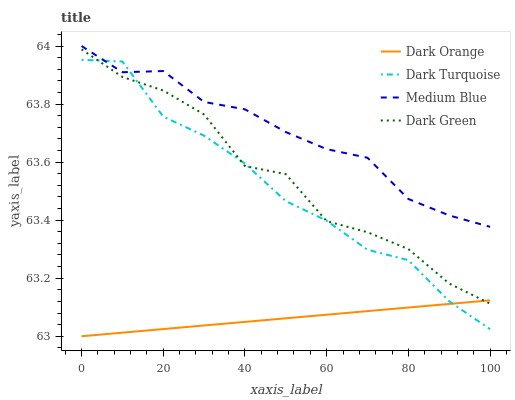Does Dark Orange have the minimum area under the curve?
Answer yes or no. Yes. Does Medium Blue have the maximum area under the curve?
Answer yes or no. Yes. Does Dark Green have the minimum area under the curve?
Answer yes or no. No. Does Dark Green have the maximum area under the curve?
Answer yes or no. No. Is Dark Orange the smoothest?
Answer yes or no. Yes. Is Dark Green the roughest?
Answer yes or no. Yes. Is Medium Blue the smoothest?
Answer yes or no. No. Is Medium Blue the roughest?
Answer yes or no. No. Does Dark Orange have the lowest value?
Answer yes or no. Yes. Does Dark Green have the lowest value?
Answer yes or no. No. Does Medium Blue have the highest value?
Answer yes or no. Yes. Does Dark Green have the highest value?
Answer yes or no. No. Is Dark Green less than Medium Blue?
Answer yes or no. Yes. Is Medium Blue greater than Dark Orange?
Answer yes or no. Yes. Does Dark Turquoise intersect Medium Blue?
Answer yes or no. Yes. Is Dark Turquoise less than Medium Blue?
Answer yes or no. No. Is Dark Turquoise greater than Medium Blue?
Answer yes or no. No. Does Dark Green intersect Medium Blue?
Answer yes or no. No. 